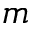Convert formula to latex. <formula><loc_0><loc_0><loc_500><loc_500>m</formula> 